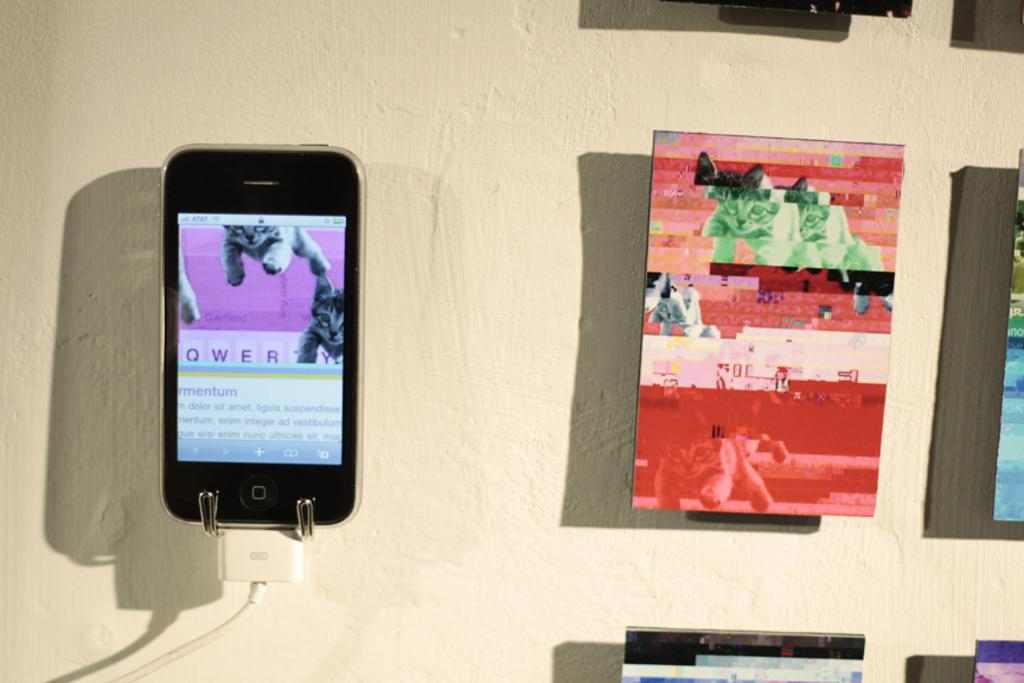What is connected to a cable in the image? There is a mobile connected to a cable in the image. Where is the mobile located? The mobile is hanging on the wall. What else can be seen hanging on the wall in the image? There are frames hanging on the wall beside the mobile. What type of fact can be seen in the image? There is no fact present in the image; it features a mobile connected to a cable and frames hanging on the wall. 